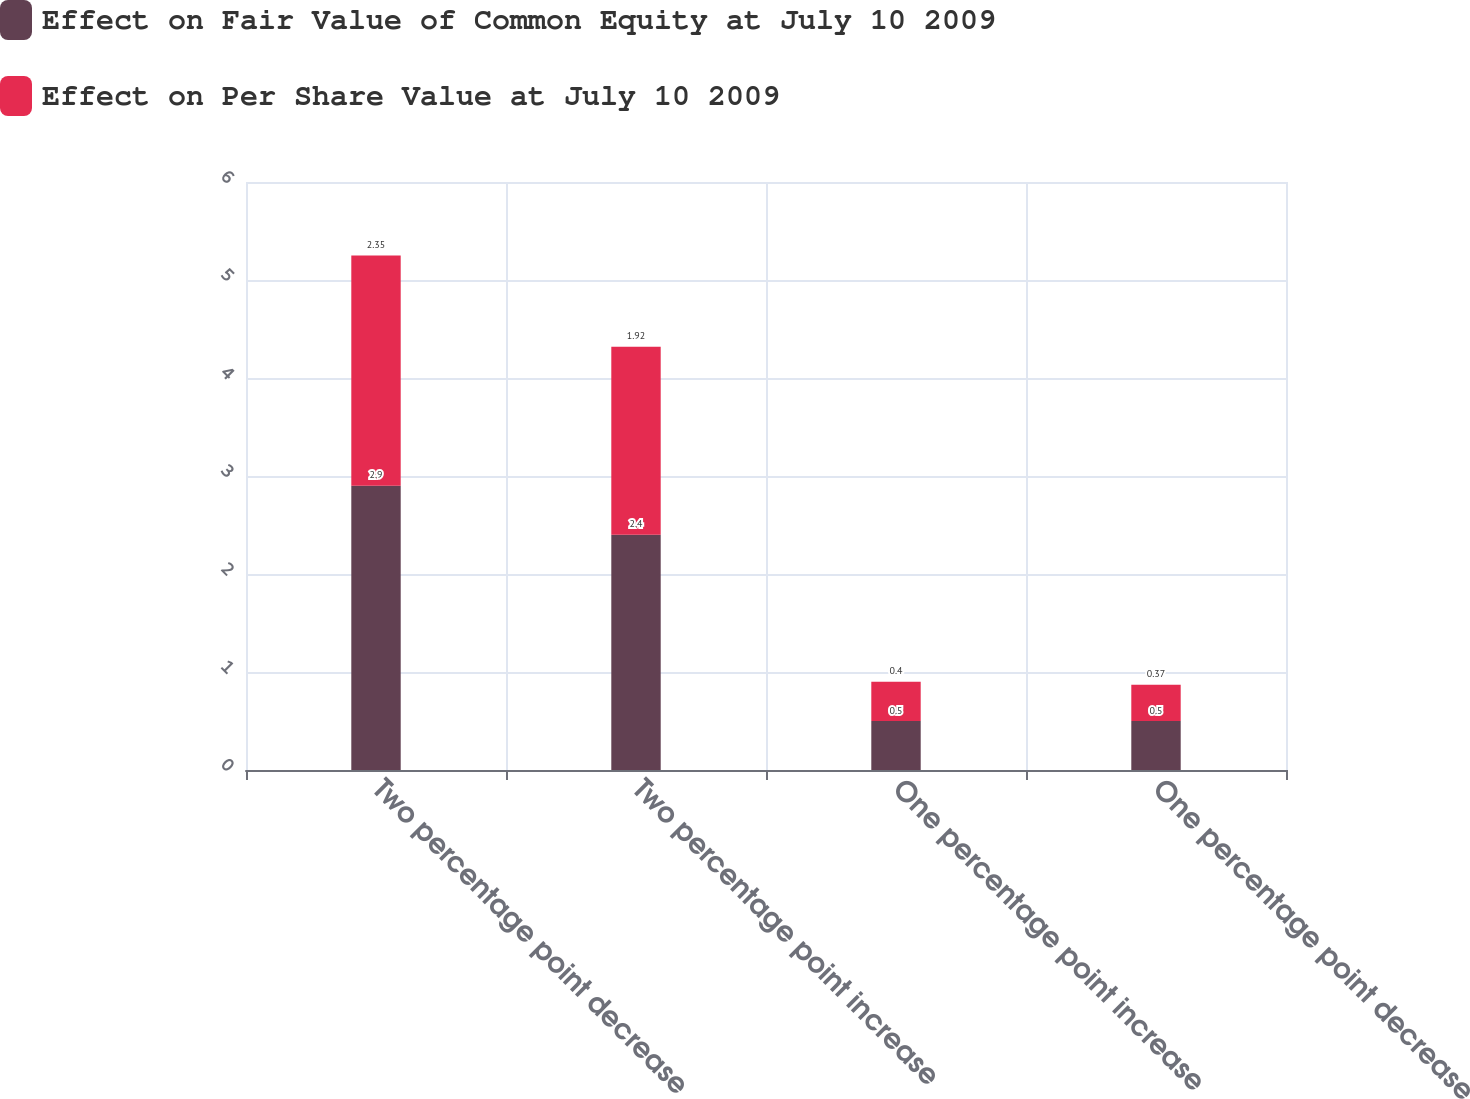<chart> <loc_0><loc_0><loc_500><loc_500><stacked_bar_chart><ecel><fcel>Two percentage point decrease<fcel>Two percentage point increase<fcel>One percentage point increase<fcel>One percentage point decrease<nl><fcel>Effect on Fair Value of Common Equity at July 10 2009<fcel>2.9<fcel>2.4<fcel>0.5<fcel>0.5<nl><fcel>Effect on Per Share Value at July 10 2009<fcel>2.35<fcel>1.92<fcel>0.4<fcel>0.37<nl></chart> 